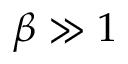Convert formula to latex. <formula><loc_0><loc_0><loc_500><loc_500>\beta \gg 1</formula> 